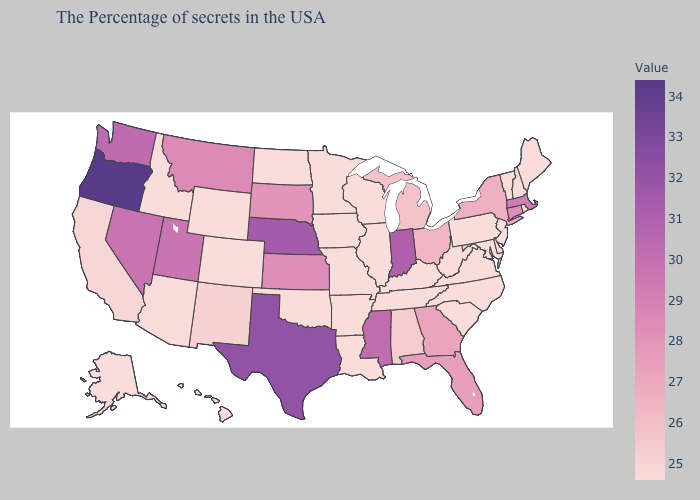Which states have the lowest value in the USA?
Write a very short answer. Maine, Rhode Island, New Hampshire, Vermont, New Jersey, Delaware, Maryland, Pennsylvania, Virginia, North Carolina, South Carolina, West Virginia, Kentucky, Tennessee, Wisconsin, Illinois, Louisiana, Missouri, Arkansas, Minnesota, Iowa, Oklahoma, North Dakota, Wyoming, Colorado, Idaho, Alaska, Hawaii. Among the states that border Nevada , which have the lowest value?
Write a very short answer. Idaho. Among the states that border South Dakota , does Nebraska have the highest value?
Keep it brief. Yes. Does Georgia have the lowest value in the USA?
Write a very short answer. No. Which states have the highest value in the USA?
Be succinct. Oregon. 